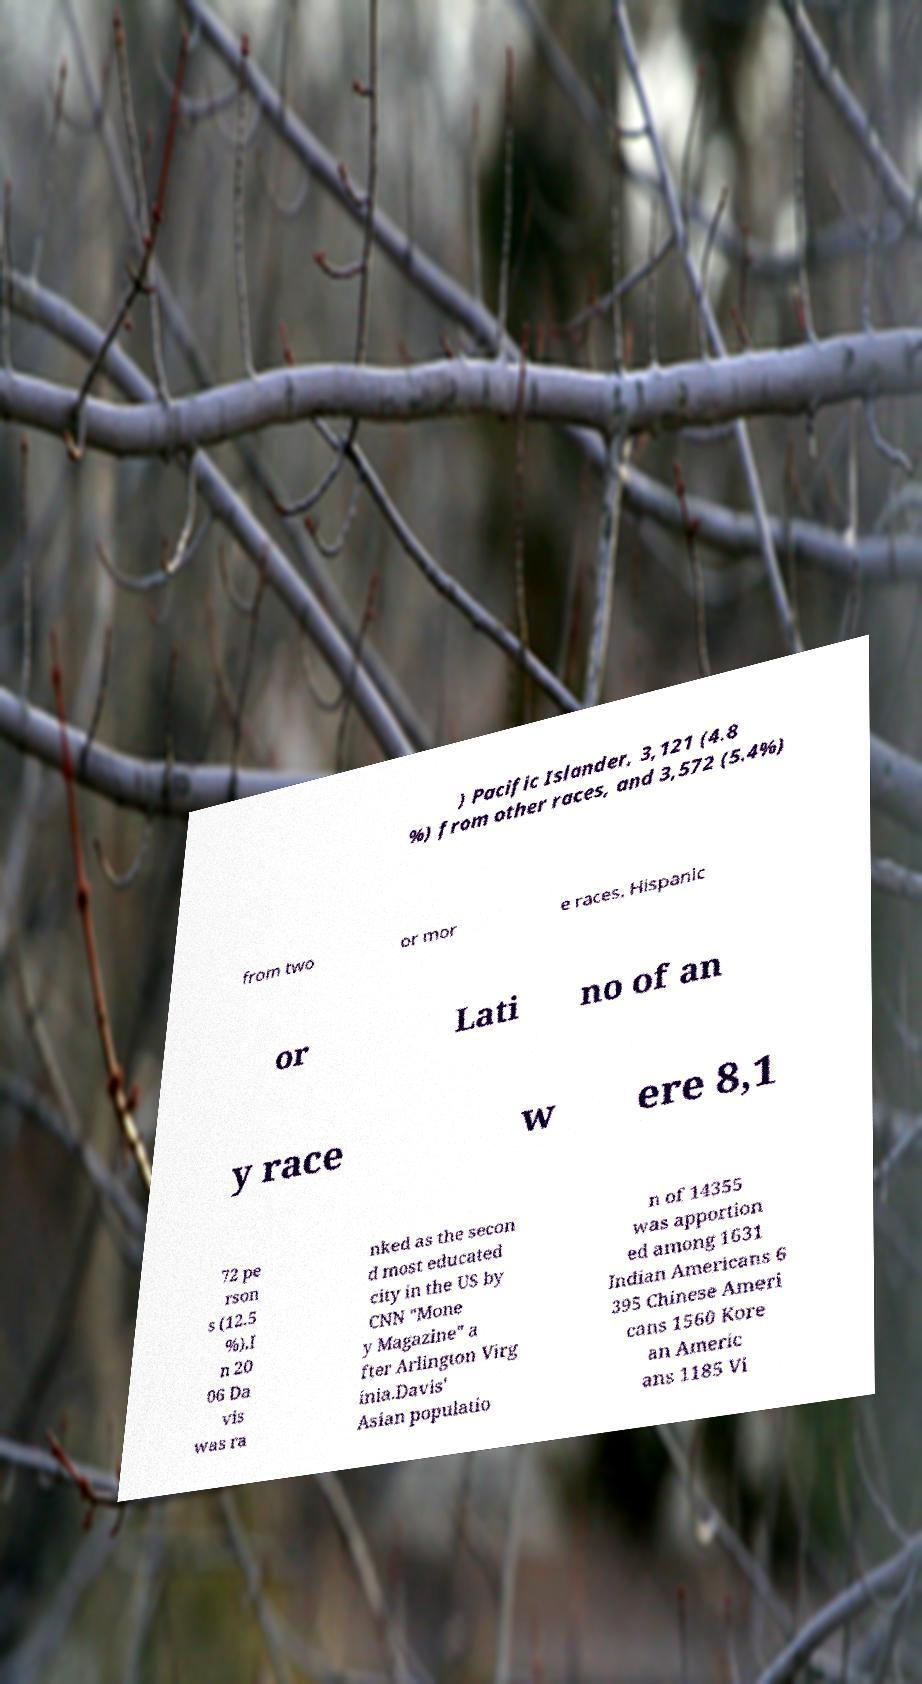Could you assist in decoding the text presented in this image and type it out clearly? ) Pacific Islander, 3,121 (4.8 %) from other races, and 3,572 (5.4%) from two or mor e races. Hispanic or Lati no of an y race w ere 8,1 72 pe rson s (12.5 %).I n 20 06 Da vis was ra nked as the secon d most educated city in the US by CNN "Mone y Magazine" a fter Arlington Virg inia.Davis' Asian populatio n of 14355 was apportion ed among 1631 Indian Americans 6 395 Chinese Ameri cans 1560 Kore an Americ ans 1185 Vi 